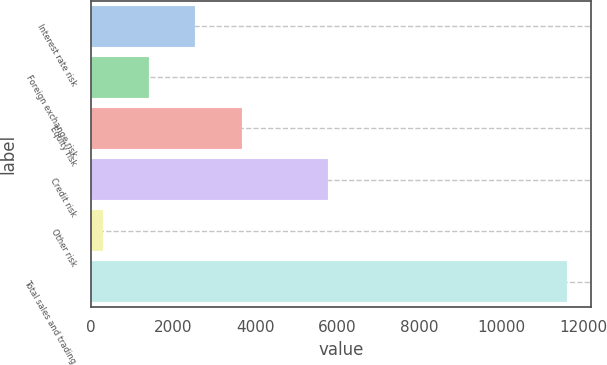<chart> <loc_0><loc_0><loc_500><loc_500><bar_chart><fcel>Interest rate risk<fcel>Foreign exchange risk<fcel>Equity risk<fcel>Credit risk<fcel>Other risk<fcel>Total sales and trading<nl><fcel>2544.6<fcel>1411.8<fcel>3677.4<fcel>5778<fcel>279<fcel>11607<nl></chart> 